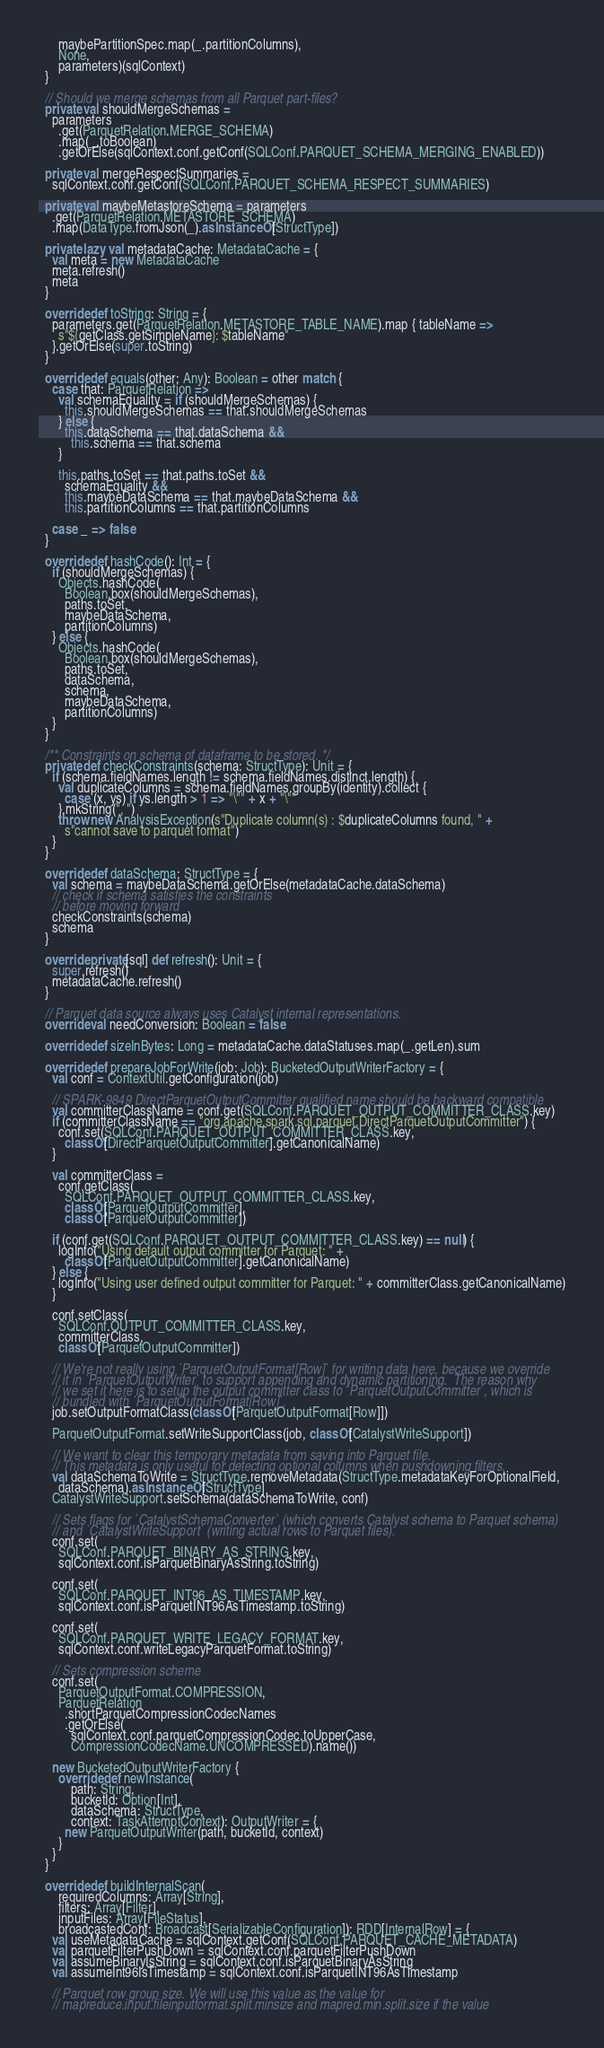<code> <loc_0><loc_0><loc_500><loc_500><_Scala_>      maybePartitionSpec.map(_.partitionColumns),
      None,
      parameters)(sqlContext)
  }

  // Should we merge schemas from all Parquet part-files?
  private val shouldMergeSchemas =
    parameters
      .get(ParquetRelation.MERGE_SCHEMA)
      .map(_.toBoolean)
      .getOrElse(sqlContext.conf.getConf(SQLConf.PARQUET_SCHEMA_MERGING_ENABLED))

  private val mergeRespectSummaries =
    sqlContext.conf.getConf(SQLConf.PARQUET_SCHEMA_RESPECT_SUMMARIES)

  private val maybeMetastoreSchema = parameters
    .get(ParquetRelation.METASTORE_SCHEMA)
    .map(DataType.fromJson(_).asInstanceOf[StructType])

  private lazy val metadataCache: MetadataCache = {
    val meta = new MetadataCache
    meta.refresh()
    meta
  }

  override def toString: String = {
    parameters.get(ParquetRelation.METASTORE_TABLE_NAME).map { tableName =>
      s"${getClass.getSimpleName}: $tableName"
    }.getOrElse(super.toString)
  }

  override def equals(other: Any): Boolean = other match {
    case that: ParquetRelation =>
      val schemaEquality = if (shouldMergeSchemas) {
        this.shouldMergeSchemas == that.shouldMergeSchemas
      } else {
        this.dataSchema == that.dataSchema &&
          this.schema == that.schema
      }

      this.paths.toSet == that.paths.toSet &&
        schemaEquality &&
        this.maybeDataSchema == that.maybeDataSchema &&
        this.partitionColumns == that.partitionColumns

    case _ => false
  }

  override def hashCode(): Int = {
    if (shouldMergeSchemas) {
      Objects.hashCode(
        Boolean.box(shouldMergeSchemas),
        paths.toSet,
        maybeDataSchema,
        partitionColumns)
    } else {
      Objects.hashCode(
        Boolean.box(shouldMergeSchemas),
        paths.toSet,
        dataSchema,
        schema,
        maybeDataSchema,
        partitionColumns)
    }
  }

  /** Constraints on schema of dataframe to be stored. */
  private def checkConstraints(schema: StructType): Unit = {
    if (schema.fieldNames.length != schema.fieldNames.distinct.length) {
      val duplicateColumns = schema.fieldNames.groupBy(identity).collect {
        case (x, ys) if ys.length > 1 => "\"" + x + "\""
      }.mkString(", ")
      throw new AnalysisException(s"Duplicate column(s) : $duplicateColumns found, " +
        s"cannot save to parquet format")
    }
  }

  override def dataSchema: StructType = {
    val schema = maybeDataSchema.getOrElse(metadataCache.dataSchema)
    // check if schema satisfies the constraints
    // before moving forward
    checkConstraints(schema)
    schema
  }

  override private[sql] def refresh(): Unit = {
    super.refresh()
    metadataCache.refresh()
  }

  // Parquet data source always uses Catalyst internal representations.
  override val needConversion: Boolean = false

  override def sizeInBytes: Long = metadataCache.dataStatuses.map(_.getLen).sum

  override def prepareJobForWrite(job: Job): BucketedOutputWriterFactory = {
    val conf = ContextUtil.getConfiguration(job)

    // SPARK-9849 DirectParquetOutputCommitter qualified name should be backward compatible
    val committerClassName = conf.get(SQLConf.PARQUET_OUTPUT_COMMITTER_CLASS.key)
    if (committerClassName == "org.apache.spark.sql.parquet.DirectParquetOutputCommitter") {
      conf.set(SQLConf.PARQUET_OUTPUT_COMMITTER_CLASS.key,
        classOf[DirectParquetOutputCommitter].getCanonicalName)
    }

    val committerClass =
      conf.getClass(
        SQLConf.PARQUET_OUTPUT_COMMITTER_CLASS.key,
        classOf[ParquetOutputCommitter],
        classOf[ParquetOutputCommitter])

    if (conf.get(SQLConf.PARQUET_OUTPUT_COMMITTER_CLASS.key) == null) {
      logInfo("Using default output committer for Parquet: " +
        classOf[ParquetOutputCommitter].getCanonicalName)
    } else {
      logInfo("Using user defined output committer for Parquet: " + committerClass.getCanonicalName)
    }

    conf.setClass(
      SQLConf.OUTPUT_COMMITTER_CLASS.key,
      committerClass,
      classOf[ParquetOutputCommitter])

    // We're not really using `ParquetOutputFormat[Row]` for writing data here, because we override
    // it in `ParquetOutputWriter` to support appending and dynamic partitioning.  The reason why
    // we set it here is to setup the output committer class to `ParquetOutputCommitter`, which is
    // bundled with `ParquetOutputFormat[Row]`.
    job.setOutputFormatClass(classOf[ParquetOutputFormat[Row]])

    ParquetOutputFormat.setWriteSupportClass(job, classOf[CatalystWriteSupport])

    // We want to clear this temporary metadata from saving into Parquet file.
    // This metadata is only useful for detecting optional columns when pushdowning filters.
    val dataSchemaToWrite = StructType.removeMetadata(StructType.metadataKeyForOptionalField,
      dataSchema).asInstanceOf[StructType]
    CatalystWriteSupport.setSchema(dataSchemaToWrite, conf)

    // Sets flags for `CatalystSchemaConverter` (which converts Catalyst schema to Parquet schema)
    // and `CatalystWriteSupport` (writing actual rows to Parquet files).
    conf.set(
      SQLConf.PARQUET_BINARY_AS_STRING.key,
      sqlContext.conf.isParquetBinaryAsString.toString)

    conf.set(
      SQLConf.PARQUET_INT96_AS_TIMESTAMP.key,
      sqlContext.conf.isParquetINT96AsTimestamp.toString)

    conf.set(
      SQLConf.PARQUET_WRITE_LEGACY_FORMAT.key,
      sqlContext.conf.writeLegacyParquetFormat.toString)

    // Sets compression scheme
    conf.set(
      ParquetOutputFormat.COMPRESSION,
      ParquetRelation
        .shortParquetCompressionCodecNames
        .getOrElse(
          sqlContext.conf.parquetCompressionCodec.toUpperCase,
          CompressionCodecName.UNCOMPRESSED).name())

    new BucketedOutputWriterFactory {
      override def newInstance(
          path: String,
          bucketId: Option[Int],
          dataSchema: StructType,
          context: TaskAttemptContext): OutputWriter = {
        new ParquetOutputWriter(path, bucketId, context)
      }
    }
  }

  override def buildInternalScan(
      requiredColumns: Array[String],
      filters: Array[Filter],
      inputFiles: Array[FileStatus],
      broadcastedConf: Broadcast[SerializableConfiguration]): RDD[InternalRow] = {
    val useMetadataCache = sqlContext.getConf(SQLConf.PARQUET_CACHE_METADATA)
    val parquetFilterPushDown = sqlContext.conf.parquetFilterPushDown
    val assumeBinaryIsString = sqlContext.conf.isParquetBinaryAsString
    val assumeInt96IsTimestamp = sqlContext.conf.isParquetINT96AsTimestamp

    // Parquet row group size. We will use this value as the value for
    // mapreduce.input.fileinputformat.split.minsize and mapred.min.split.size if the value</code> 